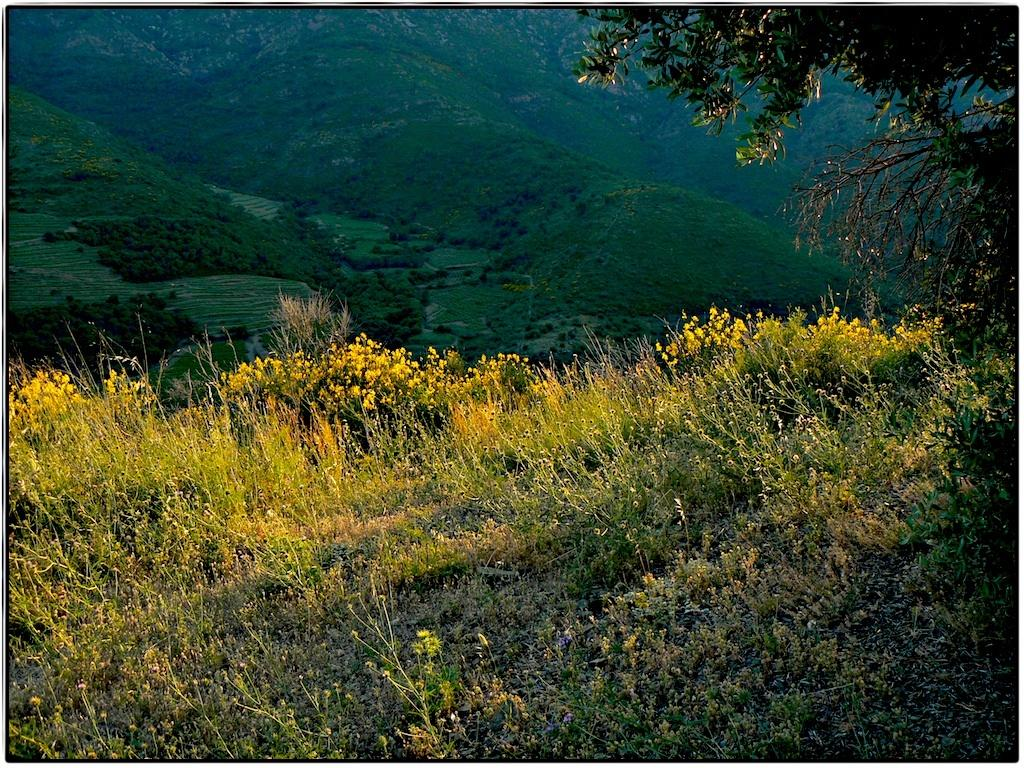What is located in the foreground of the image? There is a group of plants in the foreground of the image. What can be seen in the background of the image? There is a tree and mountains visible in the background of the image. How many stars can be seen in the image? There are no stars visible in the image; it features plants, a tree, and mountains. What type of birds are flying over the mountains in the image? There are no birds present in the image; it only shows plants, a tree, and mountains. 